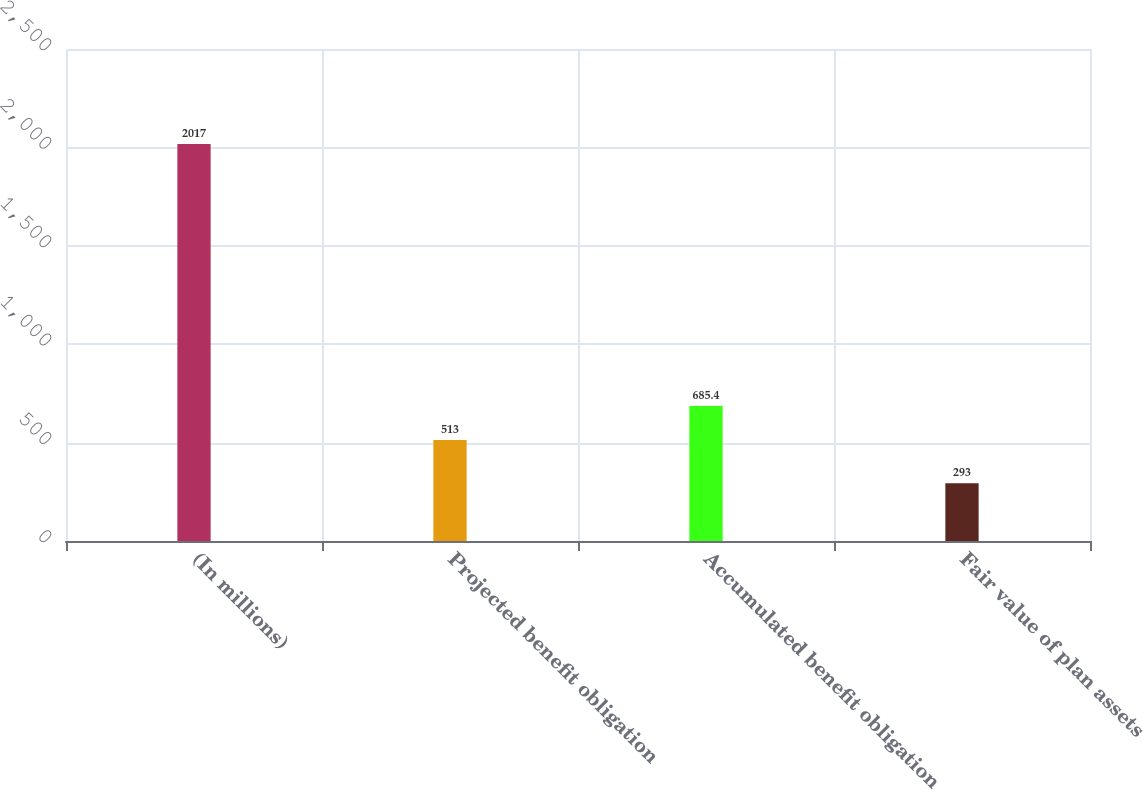Convert chart. <chart><loc_0><loc_0><loc_500><loc_500><bar_chart><fcel>(In millions)<fcel>Projected benefit obligation<fcel>Accumulated benefit obligation<fcel>Fair value of plan assets<nl><fcel>2017<fcel>513<fcel>685.4<fcel>293<nl></chart> 